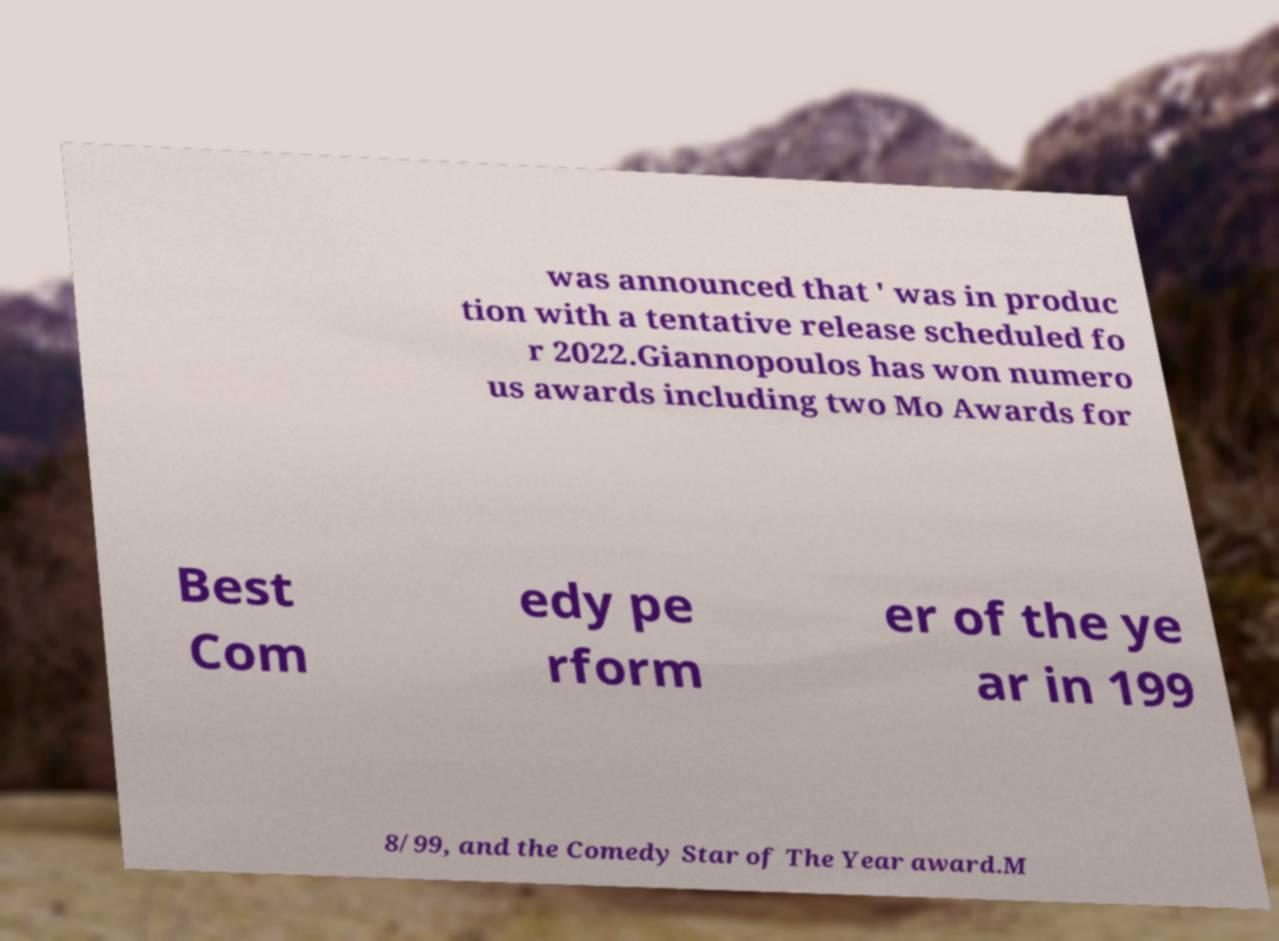Please identify and transcribe the text found in this image. was announced that ' was in produc tion with a tentative release scheduled fo r 2022.Giannopoulos has won numero us awards including two Mo Awards for Best Com edy pe rform er of the ye ar in 199 8/99, and the Comedy Star of The Year award.M 